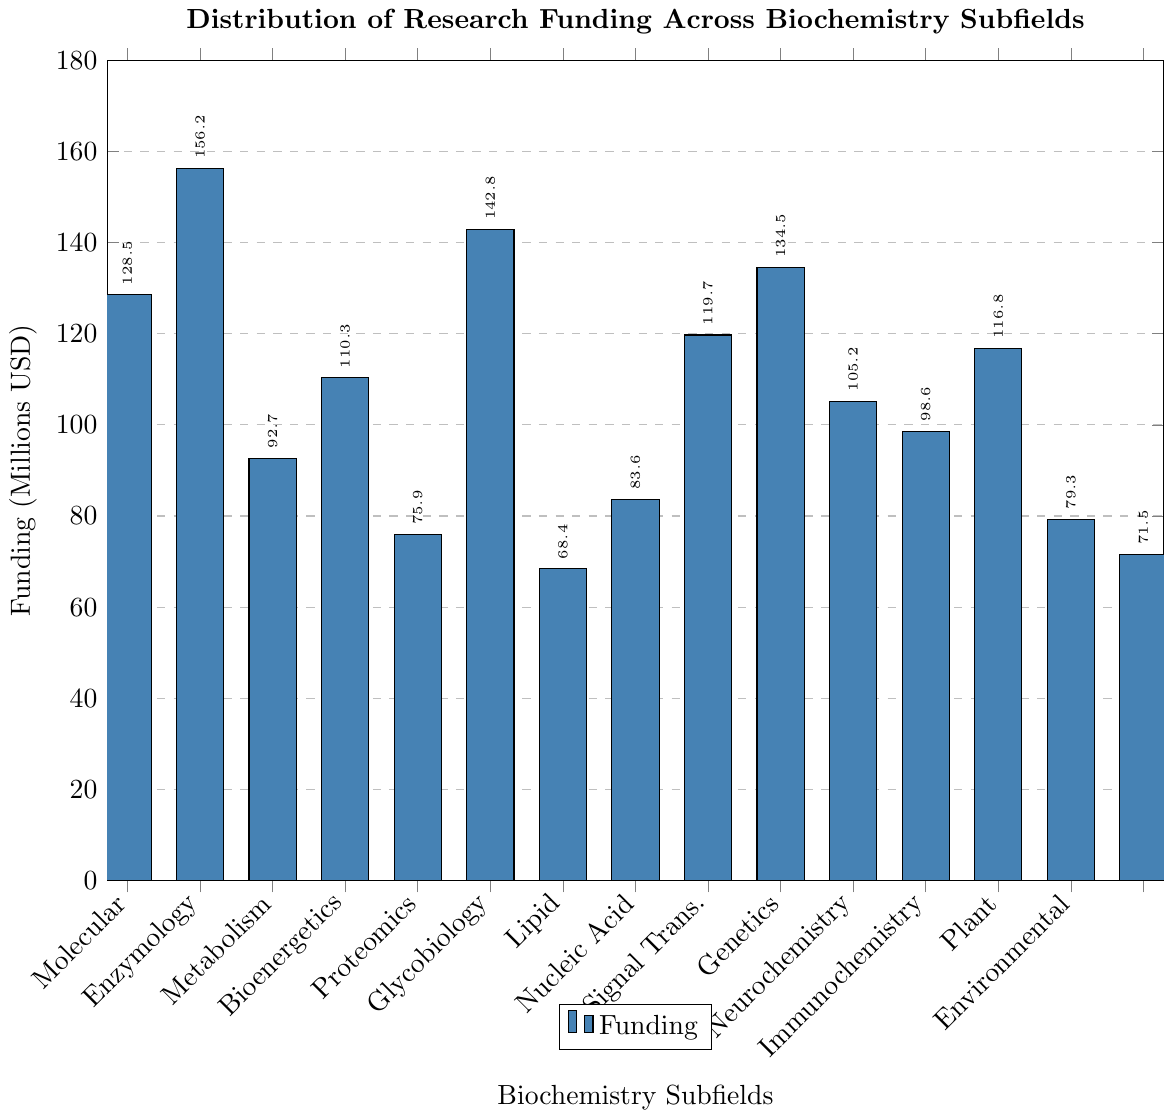What is the total funding for Structural Biochemistry and Molecular Biology combined? First, locate the bars corresponding to Structural Biochemistry and Molecular Biology. Their funding amounts are 128.5 million USD and 156.2 million USD respectively. Adding these amounts gives 128.5 + 156.2 = 284.7 million USD.
Answer: 284.7 million USD Which subfield has the least amount of funding? Identify the bar with the shortest height. The subfield with the shortest bar is Glycobiology with 68.4 million USD.
Answer: Glycobiology What is the difference in funding between Proteomics and Lipid Biochemistry? The funding for Proteomics is 142.8 million USD and for Lipid Biochemistry, it is 83.6 million USD. Subtract the latter from the former: 142.8 - 83.6 = 59.2 million USD.
Answer: 59.2 million USD Which subfields have funding amounts greater than 100 million USD? Identify the bars exceeding the 100 million USD mark. These are Structural Biochemistry (128.5), Molecular Biology (156.2), Proteomics (142.8), Nucleic Acid Biochemistry (119.7), Signal Transduction (134.5), and Biochemical Genetics (105.2).
Answer: Structural Biochemistry, Molecular Biology, Proteomics, Nucleic Acid Biochemistry, Signal Transduction, Biochemical Genetics How does the funding for Bioenergetics compare to that of Plant Biochemistry? The bar for Bioenergetics shows 75.9 million USD, while Plant Biochemistry has 79.3 million USD. Comparing these, Plant Biochemistry receives slightly more funding than Bioenergetics.
Answer: Plant Biochemistry has slightly more funding than Bioenergetics What is the average funding amount for all subfields? Add all the funding amounts: 128.5 + 156.2 + 92.7 + 110.3 + 75.9 + 142.8 + 68.4 + 83.6 + 119.7 + 134.5 + 105.2 + 98.6 + 116.8 + 79.3 + 71.5 = 1584 million USD. There are 15 subfields, so average funding is 1584 / 15 = 105.6 million USD.
Answer: 105.6 million USD Which has higher funding, Neurochemistry or Environmental Biochemistry? Compare the heights of the bars for Neurochemistry (98.6 million USD) and Environmental Biochemistry (71.5 million USD). Neurochemistry has higher funding.
Answer: Neurochemistry What is the median funding amount of all subfields? Arrange the funding values in ascending order: 68.4, 71.5, 75.9, 79.3, 83.6, 92.7, 98.6, 105.2, 110.3, 116.8, 119.7, 128.5, 134.5, 142.8, 156.2. With an odd number of values (15), the median is the 8th value: 105.2 million USD.
Answer: 105.2 million USD Which subfield receives nearly half of the funding of Molecular Biology? Molecular Biology receives 156.2 million USD. Half of this is 78.1 million USD. The subfield with funding close to this amount is Plant Biochemistry with 79.3 million USD.
Answer: Plant Biochemistry How many subfields receive less than 100 million USD in funding? Identify bars below the 100 million USD mark. These are Enzymology (92.7), Bioenergetics (75.9), Glycobiology (68.4), Lipid Biochemistry (83.6), Neurochemistry (98.6), Plant Biochemistry (79.3), and Environmental Biochemistry (71.5), totaling 7 subfields.
Answer: 7 